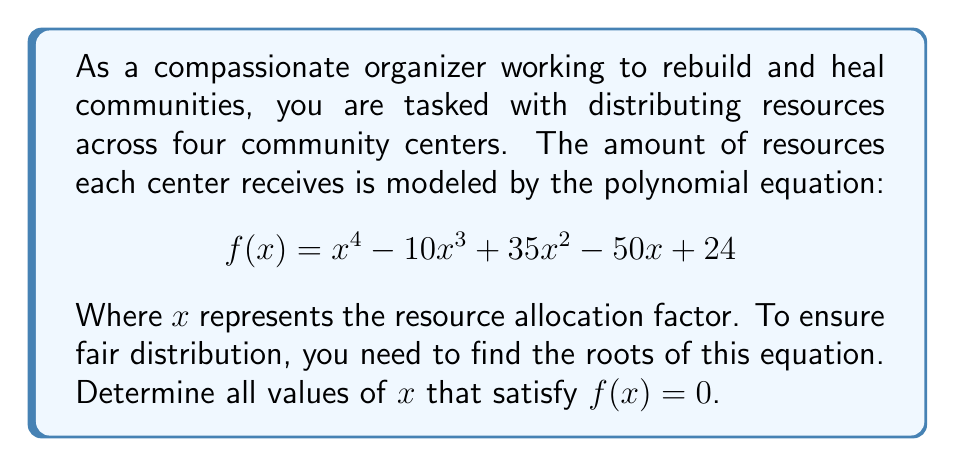Could you help me with this problem? To find the roots of this polynomial equation, we'll use factoring techniques:

1) First, let's check if there are any rational roots using the rational root theorem. The possible rational roots are factors of the constant term 24: ±1, ±2, ±3, ±4, ±6, ±8, ±12, ±24.

2) By testing these values, we find that $x = 1$ and $x = 4$ are roots of the equation.

3) We can factor out $(x-1)$ and $(x-4)$:

   $$f(x) = (x-1)(x-4)(ax^2 + bx + c)$$

4) Expanding this and comparing coefficients with the original equation, we can determine that $a = 1$, $b = -5$, and $c = 6$.

5) So our equation becomes:

   $$f(x) = (x-1)(x-4)(x^2 - 5x + 6)$$

6) The quadratic factor $x^2 - 5x + 6$ can be further factored:

   $$x^2 - 5x + 6 = (x-2)(x-3)$$

7) Therefore, the fully factored equation is:

   $$f(x) = (x-1)(x-2)(x-3)(x-4)$$

8) The roots of the equation are the values that make each factor equal to zero.
Answer: The roots of the equation are $x = 1$, $x = 2$, $x = 3$, and $x = 4$. 